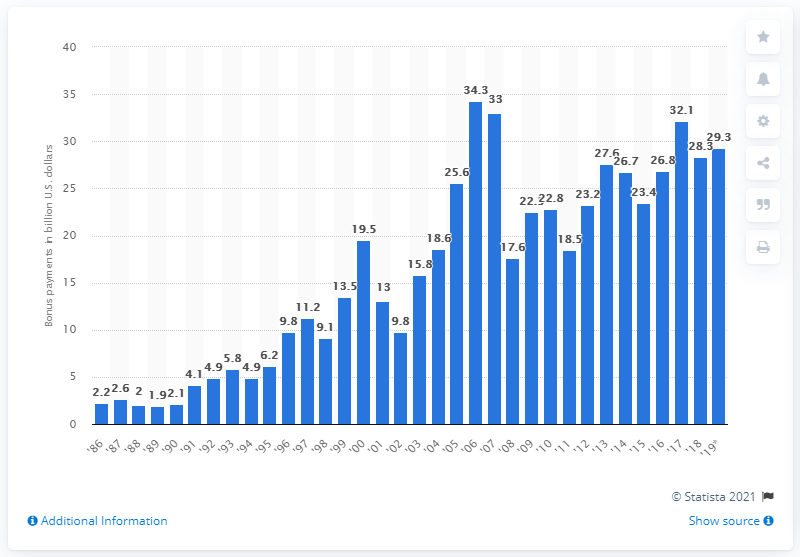Draw attention to some important aspects in this diagram. In 2019, the amount of bonuses paid to employees in the securities industry in New York was $29.3 million. 